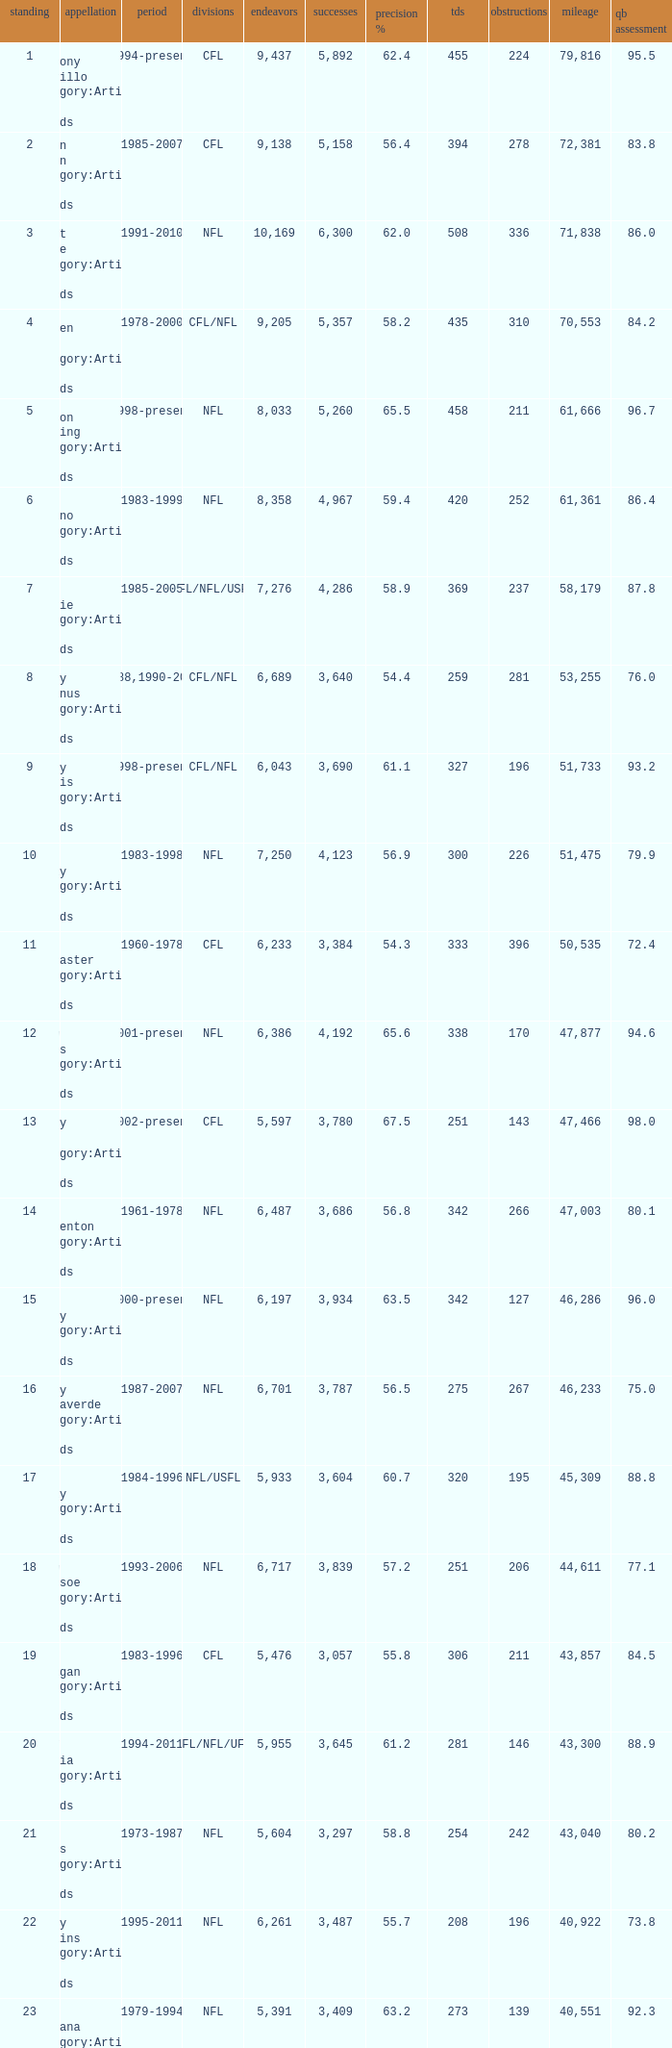What is the number of interceptions with less than 3,487 completions , more than 40,551 yardage, and the comp % is 55.8? 211.0. 